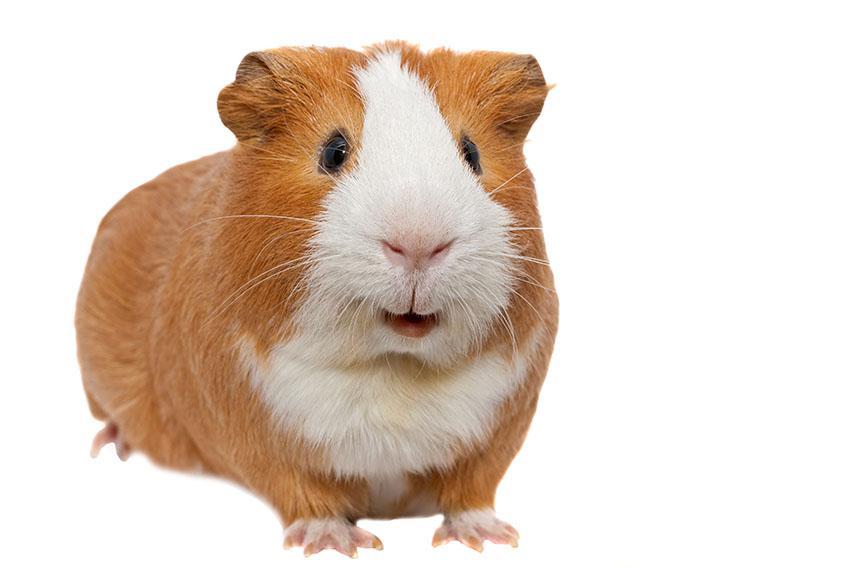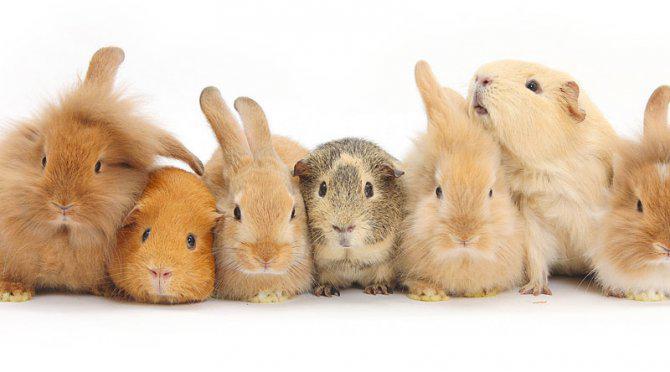The first image is the image on the left, the second image is the image on the right. For the images displayed, is the sentence "In the left image, there are two guinea pigs" factually correct? Answer yes or no. No. 